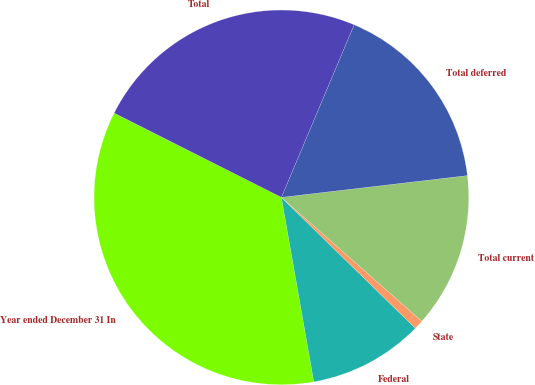Convert chart to OTSL. <chart><loc_0><loc_0><loc_500><loc_500><pie_chart><fcel>Year ended December 31 In<fcel>Federal<fcel>State<fcel>Total current<fcel>Total deferred<fcel>Total<nl><fcel>35.21%<fcel>9.92%<fcel>0.81%<fcel>13.36%<fcel>16.8%<fcel>23.92%<nl></chart> 